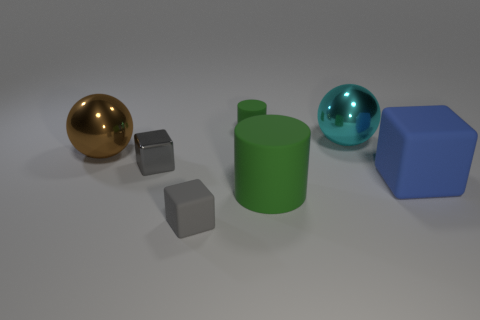Subtract all blue cubes. How many cubes are left? 2 Subtract 1 blocks. How many blocks are left? 2 Subtract all cylinders. How many objects are left? 5 Add 3 tiny purple matte things. How many objects exist? 10 Add 2 blue matte blocks. How many blue matte blocks exist? 3 Subtract 0 red cylinders. How many objects are left? 7 Subtract all green rubber objects. Subtract all balls. How many objects are left? 3 Add 7 tiny cylinders. How many tiny cylinders are left? 8 